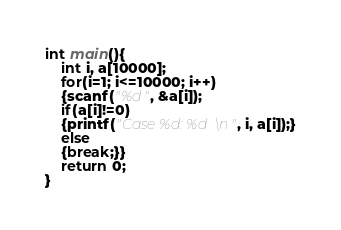Convert code to text. <code><loc_0><loc_0><loc_500><loc_500><_C_>int main(){
    int i, a[10000];
    for(i=1; i<=10000; i++)
    {scanf("%d", &a[i]);
    if(a[i]!=0)
    {printf("Case %d: %d\n", i, a[i]);}
    else
    {break;}}
    return 0;
}</code> 